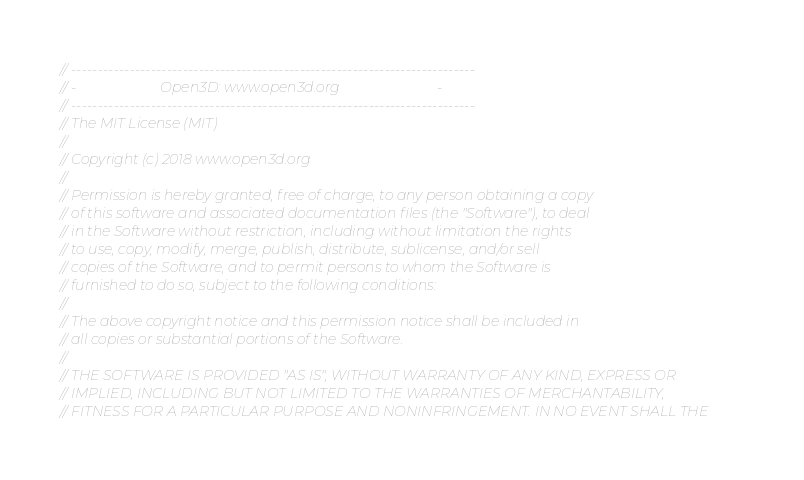Convert code to text. <code><loc_0><loc_0><loc_500><loc_500><_C++_>// ----------------------------------------------------------------------------
// -                        Open3D: www.open3d.org                            -
// ----------------------------------------------------------------------------
// The MIT License (MIT)
//
// Copyright (c) 2018 www.open3d.org
//
// Permission is hereby granted, free of charge, to any person obtaining a copy
// of this software and associated documentation files (the "Software"), to deal
// in the Software without restriction, including without limitation the rights
// to use, copy, modify, merge, publish, distribute, sublicense, and/or sell
// copies of the Software, and to permit persons to whom the Software is
// furnished to do so, subject to the following conditions:
//
// The above copyright notice and this permission notice shall be included in
// all copies or substantial portions of the Software.
//
// THE SOFTWARE IS PROVIDED "AS IS", WITHOUT WARRANTY OF ANY KIND, EXPRESS OR
// IMPLIED, INCLUDING BUT NOT LIMITED TO THE WARRANTIES OF MERCHANTABILITY,
// FITNESS FOR A PARTICULAR PURPOSE AND NONINFRINGEMENT. IN NO EVENT SHALL THE</code> 